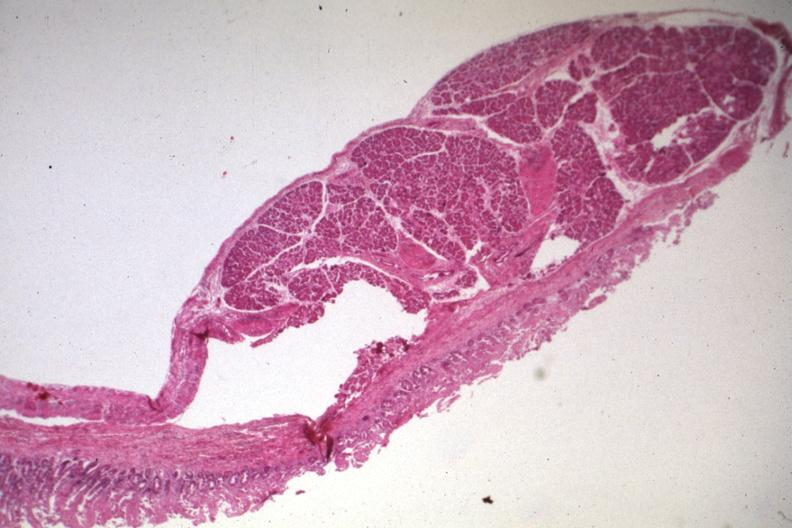where is this from?
Answer the question using a single word or phrase. Gastrointestinal system 